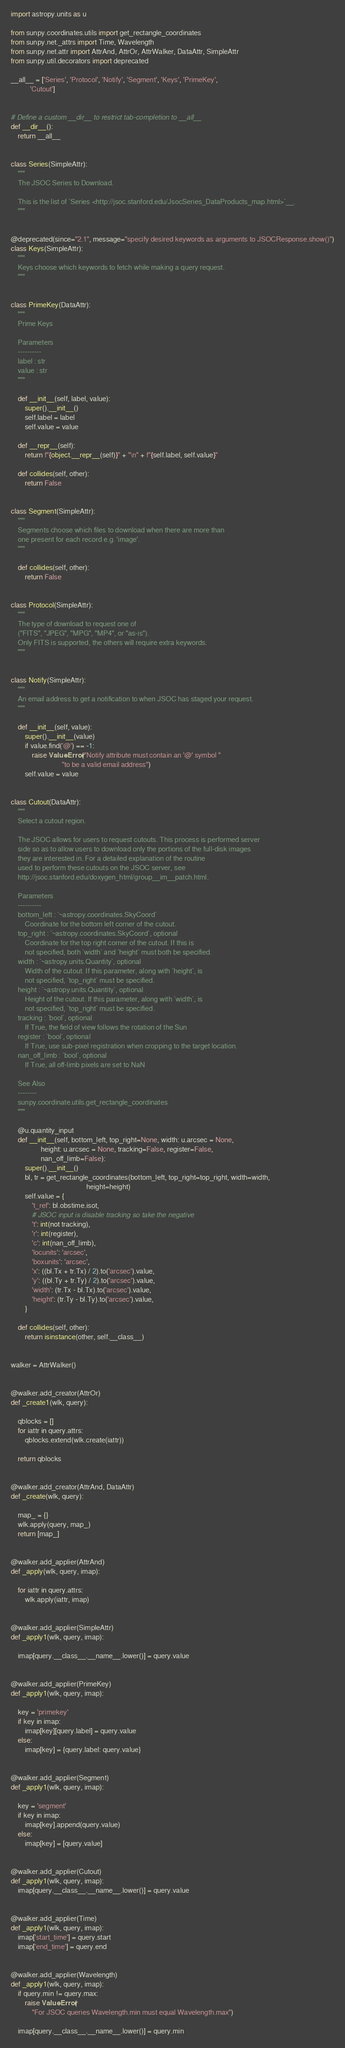<code> <loc_0><loc_0><loc_500><loc_500><_Python_>import astropy.units as u

from sunpy.coordinates.utils import get_rectangle_coordinates
from sunpy.net._attrs import Time, Wavelength
from sunpy.net.attr import AttrAnd, AttrOr, AttrWalker, DataAttr, SimpleAttr
from sunpy.util.decorators import deprecated

__all__ = ['Series', 'Protocol', 'Notify', 'Segment', 'Keys', 'PrimeKey',
           'Cutout']


# Define a custom __dir__ to restrict tab-completion to __all__
def __dir__():
    return __all__


class Series(SimpleAttr):
    """
    The JSOC Series to Download.

    This is the list of `Series <http://jsoc.stanford.edu/JsocSeries_DataProducts_map.html>`__.
    """


@deprecated(since="2.1", message="specify desired keywords as arguments to JSOCResponse.show()")
class Keys(SimpleAttr):
    """
    Keys choose which keywords to fetch while making a query request.
    """


class PrimeKey(DataAttr):
    """
    Prime Keys

    Parameters
    ----------
    label : str
    value : str
    """

    def __init__(self, label, value):
        super().__init__()
        self.label = label
        self.value = value

    def __repr__(self):
        return f"{object.__repr__(self)}" + "\n" + f"{self.label, self.value}"

    def collides(self, other):
        return False


class Segment(SimpleAttr):
    """
    Segments choose which files to download when there are more than
    one present for each record e.g. 'image'.
    """

    def collides(self, other):
        return False


class Protocol(SimpleAttr):
    """
    The type of download to request one of
    ("FITS", "JPEG", "MPG", "MP4", or "as-is").
    Only FITS is supported, the others will require extra keywords.
    """


class Notify(SimpleAttr):
    """
    An email address to get a notification to when JSOC has staged your request.
    """

    def __init__(self, value):
        super().__init__(value)
        if value.find('@') == -1:
            raise ValueError("Notify attribute must contain an '@' symbol "
                             "to be a valid email address")
        self.value = value


class Cutout(DataAttr):
    """
    Select a cutout region.

    The JSOC allows for users to request cutouts. This process is performed server
    side so as to allow users to download only the portions of the full-disk images
    they are interested in. For a detailed explanation of the routine
    used to perform these cutouts on the JSOC server, see
    http://jsoc.stanford.edu/doxygen_html/group__im__patch.html.

    Parameters
    ----------
    bottom_left : `~astropy.coordinates.SkyCoord`
        Coordinate for the bottom left corner of the cutout.
    top_right : `~astropy.coordinates.SkyCoord`, optional
        Coordinate for the top right corner of the cutout. If this is
        not specified, both `width` and `height` must both be specified.
    width : `~astropy.units.Quantity`, optional
        Width of the cutout. If this parameter, along with `height`, is
        not specified, `top_right` must be specified.
    height : `~astropy.units.Quantity`, optional
        Height of the cutout. If this parameter, along with `width`, is
        not specified, `top_right` must be specified.
    tracking : `bool`, optional
        If True, the field of view follows the rotation of the Sun
    register : `bool`, optional
        If True, use sub-pixel registration when cropping to the target location.
    nan_off_limb : `bool`, optional
        If True, all off-limb pixels are set to NaN

    See Also
    --------
    sunpy.coordinate.utils.get_rectangle_coordinates
    """

    @u.quantity_input
    def __init__(self, bottom_left, top_right=None, width: u.arcsec = None,
                 height: u.arcsec = None, tracking=False, register=False,
                 nan_off_limb=False):
        super().__init__()
        bl, tr = get_rectangle_coordinates(bottom_left, top_right=top_right, width=width,
                                           height=height)
        self.value = {
            't_ref': bl.obstime.isot,
            # JSOC input is disable tracking so take the negative
            't': int(not tracking),
            'r': int(register),
            'c': int(nan_off_limb),
            'locunits': 'arcsec',
            'boxunits': 'arcsec',
            'x': ((bl.Tx + tr.Tx) / 2).to('arcsec').value,
            'y': ((bl.Ty + tr.Ty) / 2).to('arcsec').value,
            'width': (tr.Tx - bl.Tx).to('arcsec').value,
            'height': (tr.Ty - bl.Ty).to('arcsec').value,
        }

    def collides(self, other):
        return isinstance(other, self.__class__)


walker = AttrWalker()


@walker.add_creator(AttrOr)
def _create1(wlk, query):

    qblocks = []
    for iattr in query.attrs:
        qblocks.extend(wlk.create(iattr))

    return qblocks


@walker.add_creator(AttrAnd, DataAttr)
def _create(wlk, query):

    map_ = {}
    wlk.apply(query, map_)
    return [map_]


@walker.add_applier(AttrAnd)
def _apply(wlk, query, imap):

    for iattr in query.attrs:
        wlk.apply(iattr, imap)


@walker.add_applier(SimpleAttr)
def _apply1(wlk, query, imap):

    imap[query.__class__.__name__.lower()] = query.value


@walker.add_applier(PrimeKey)
def _apply1(wlk, query, imap):

    key = 'primekey'
    if key in imap:
        imap[key][query.label] = query.value
    else:
        imap[key] = {query.label: query.value}


@walker.add_applier(Segment)
def _apply1(wlk, query, imap):

    key = 'segment'
    if key in imap:
        imap[key].append(query.value)
    else:
        imap[key] = [query.value]


@walker.add_applier(Cutout)
def _apply1(wlk, query, imap):
    imap[query.__class__.__name__.lower()] = query.value


@walker.add_applier(Time)
def _apply1(wlk, query, imap):
    imap['start_time'] = query.start
    imap['end_time'] = query.end


@walker.add_applier(Wavelength)
def _apply1(wlk, query, imap):
    if query.min != query.max:
        raise ValueError(
            "For JSOC queries Wavelength.min must equal Wavelength.max")

    imap[query.__class__.__name__.lower()] = query.min
</code> 